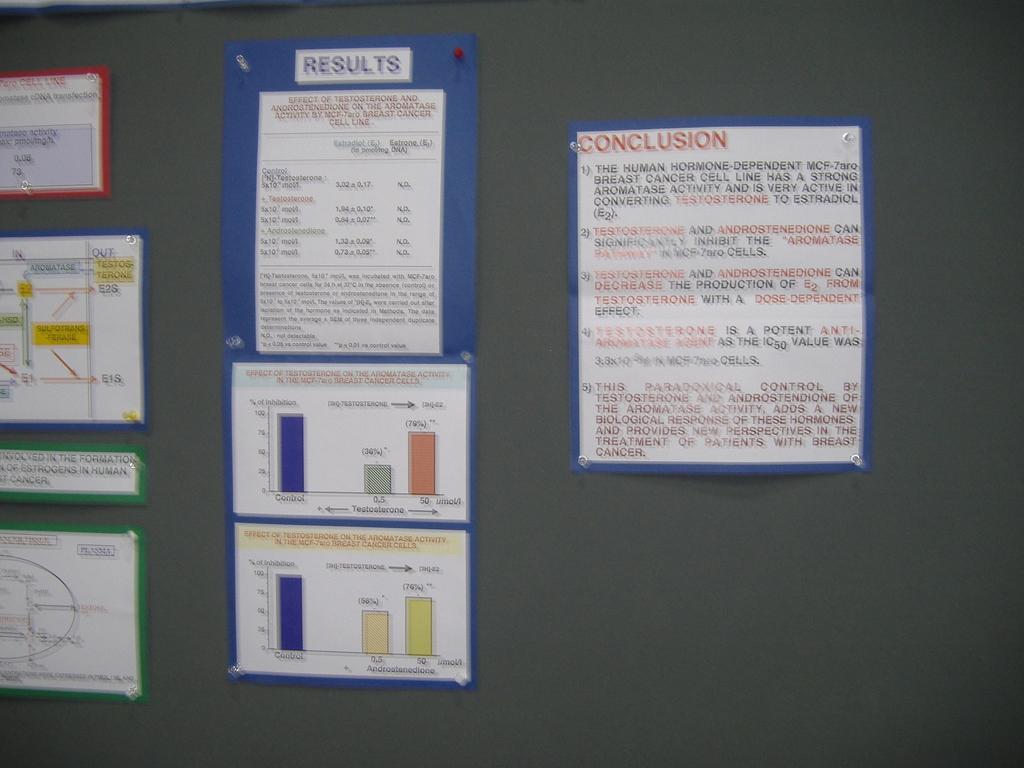Are there results for this project?
Offer a terse response. Yes. 